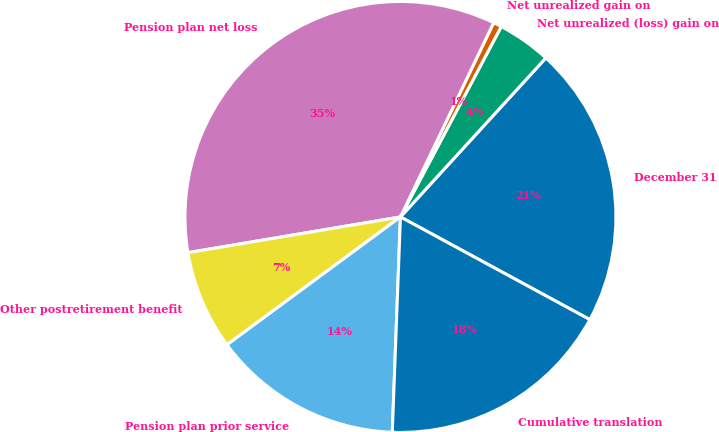Convert chart. <chart><loc_0><loc_0><loc_500><loc_500><pie_chart><fcel>December 31<fcel>Net unrealized (loss) gain on<fcel>Net unrealized gain on<fcel>Pension plan net loss<fcel>Other postretirement benefit<fcel>Pension plan prior service<fcel>Cumulative translation<nl><fcel>21.12%<fcel>4.04%<fcel>0.63%<fcel>34.78%<fcel>7.46%<fcel>14.29%<fcel>17.7%<nl></chart> 